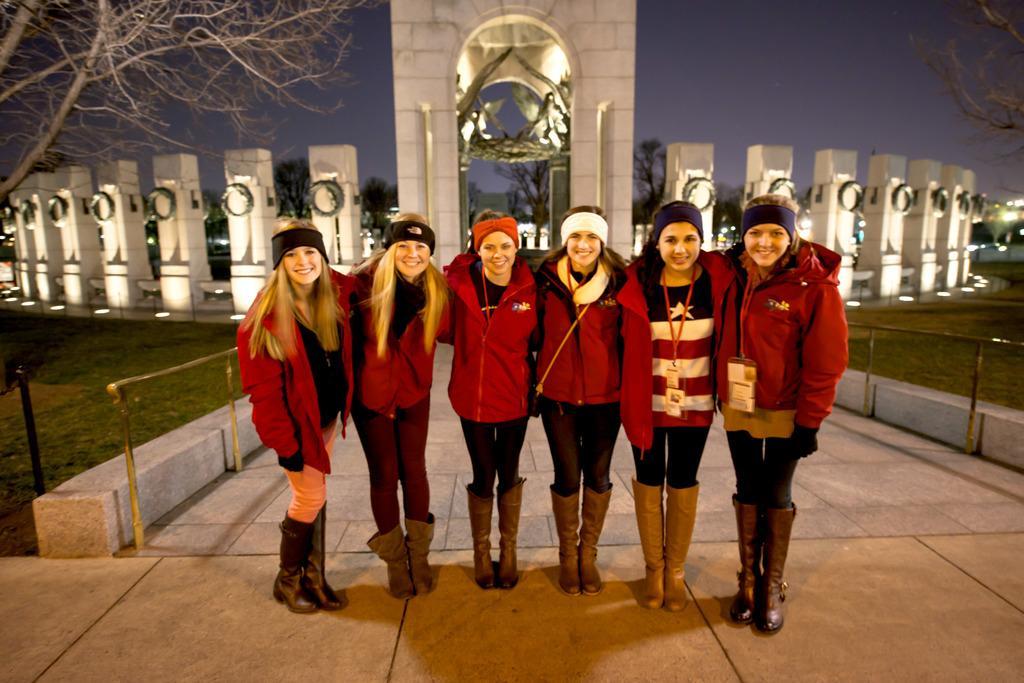Can you describe this image briefly? In the center of the image, we can see people standing and wearing coats, bands and shoes. In the background, there are trees and we can see an arch and pillars and there are lights and we can see a fence. At the top, there is sky and at the bottom, there is a road and ground. 